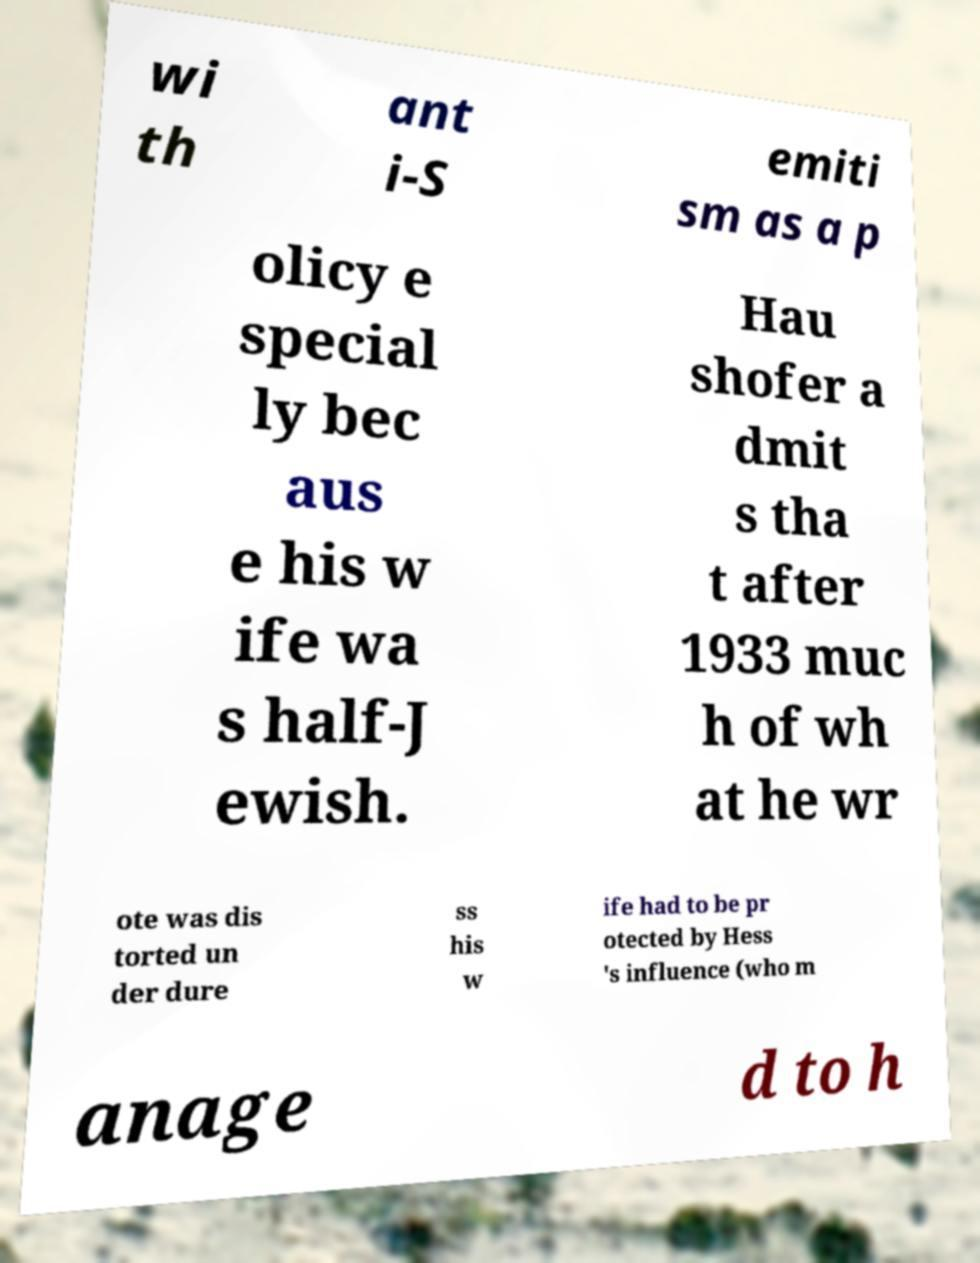For documentation purposes, I need the text within this image transcribed. Could you provide that? wi th ant i-S emiti sm as a p olicy e special ly bec aus e his w ife wa s half-J ewish. Hau shofer a dmit s tha t after 1933 muc h of wh at he wr ote was dis torted un der dure ss his w ife had to be pr otected by Hess 's influence (who m anage d to h 